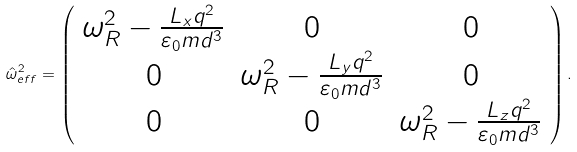<formula> <loc_0><loc_0><loc_500><loc_500>\hat { \omega } _ { e f f } ^ { 2 } = \left ( \begin{array} { c c c } \omega _ { R } ^ { 2 } - \frac { L _ { x } q ^ { 2 } } { \varepsilon _ { 0 } m d ^ { 3 } } & 0 & 0 \\ 0 & \omega _ { R } ^ { 2 } - \frac { L _ { y } q ^ { 2 } } { \varepsilon _ { 0 } m d ^ { 3 } } & 0 \\ 0 & 0 & \omega _ { R } ^ { 2 } - \frac { L _ { z } q ^ { 2 } } { \varepsilon _ { 0 } m d ^ { 3 } } \end{array} \right ) .</formula> 